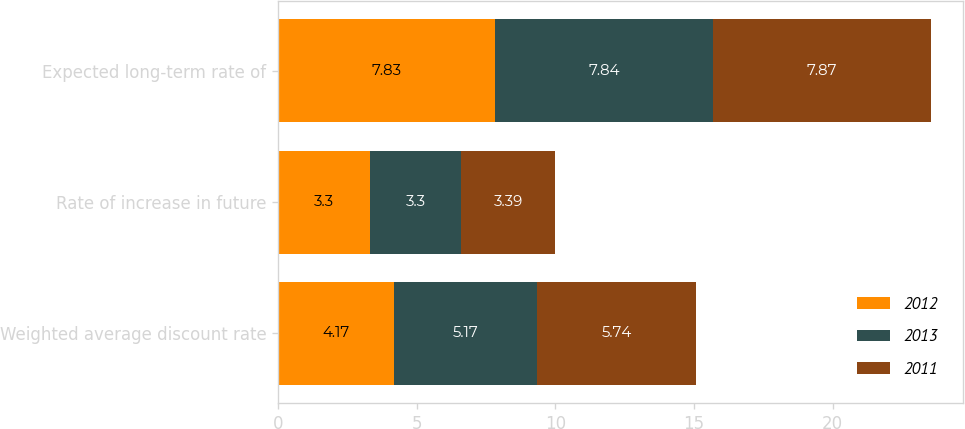Convert chart to OTSL. <chart><loc_0><loc_0><loc_500><loc_500><stacked_bar_chart><ecel><fcel>Weighted average discount rate<fcel>Rate of increase in future<fcel>Expected long-term rate of<nl><fcel>2012<fcel>4.17<fcel>3.3<fcel>7.83<nl><fcel>2013<fcel>5.17<fcel>3.3<fcel>7.84<nl><fcel>2011<fcel>5.74<fcel>3.39<fcel>7.87<nl></chart> 